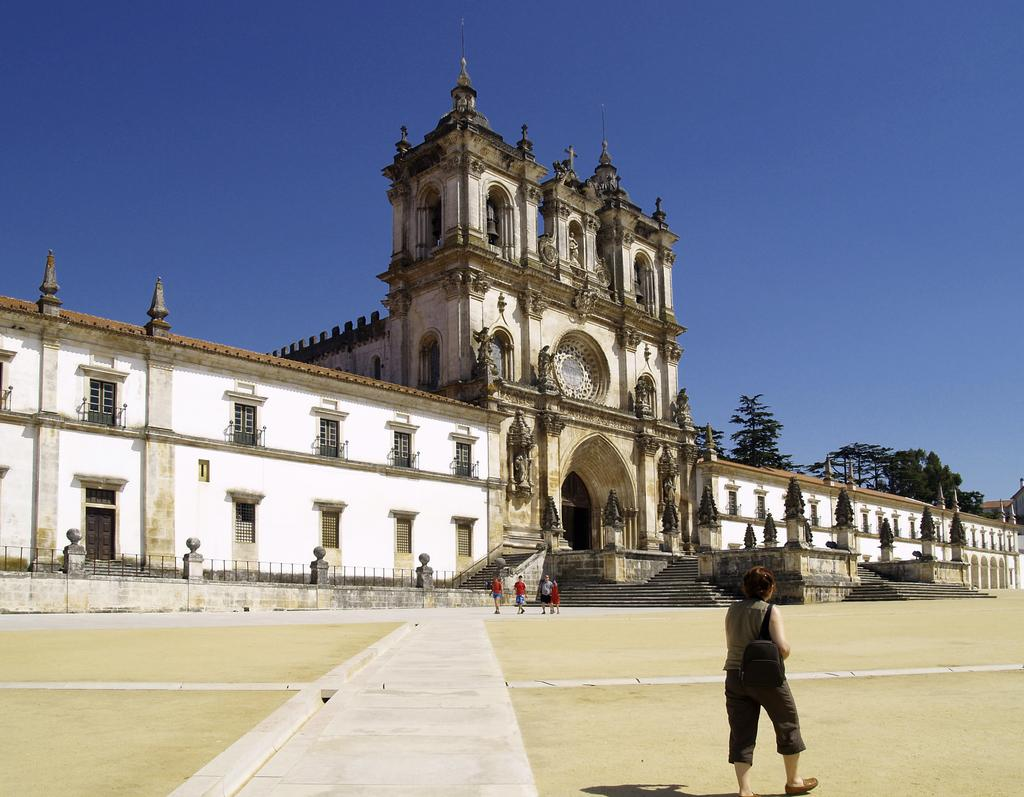What type of building is shown in the image? The image depicts a palace. What architectural features can be seen on the palace? The palace has windows, an arch, and pillars. Are there any additional structures or elements in the image? Yes, there are stairs and trees in the image. What is happening in the image involving people? There are people walking in the image. What impulse do the trees have in the image? Trees do not have impulses; they are inanimate objects. How does the palace attract the attention of the people in the image? The palace itself is not actively attracting the attention of the people in the image; they are simply walking. 